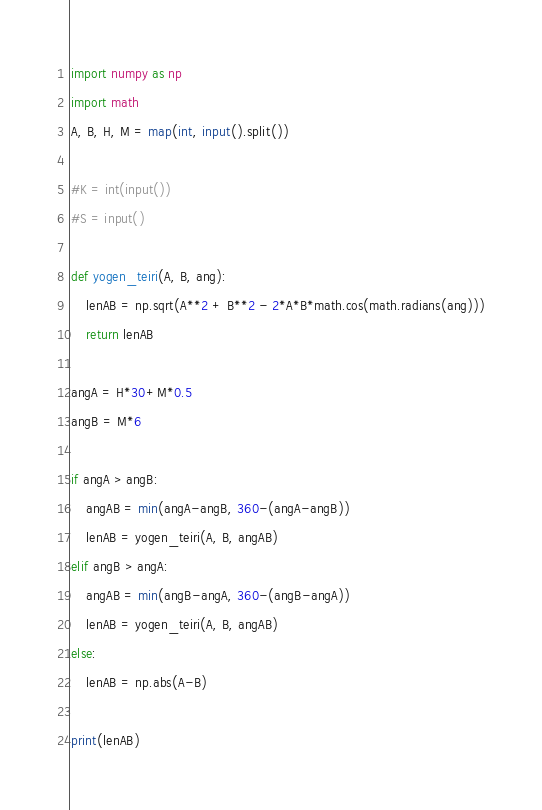<code> <loc_0><loc_0><loc_500><loc_500><_Python_>import numpy as np
import math
A, B, H, M = map(int, input().split())

#K = int(input())
#S = input()

def yogen_teiri(A, B, ang):
    lenAB = np.sqrt(A**2 + B**2 - 2*A*B*math.cos(math.radians(ang)))
    return lenAB

angA = H*30+M*0.5
angB = M*6

if angA > angB:
    angAB = min(angA-angB, 360-(angA-angB))
    lenAB = yogen_teiri(A, B, angAB)
elif angB > angA:
    angAB = min(angB-angA, 360-(angB-angA))
    lenAB = yogen_teiri(A, B, angAB)
else:
    lenAB = np.abs(A-B)

print(lenAB)</code> 